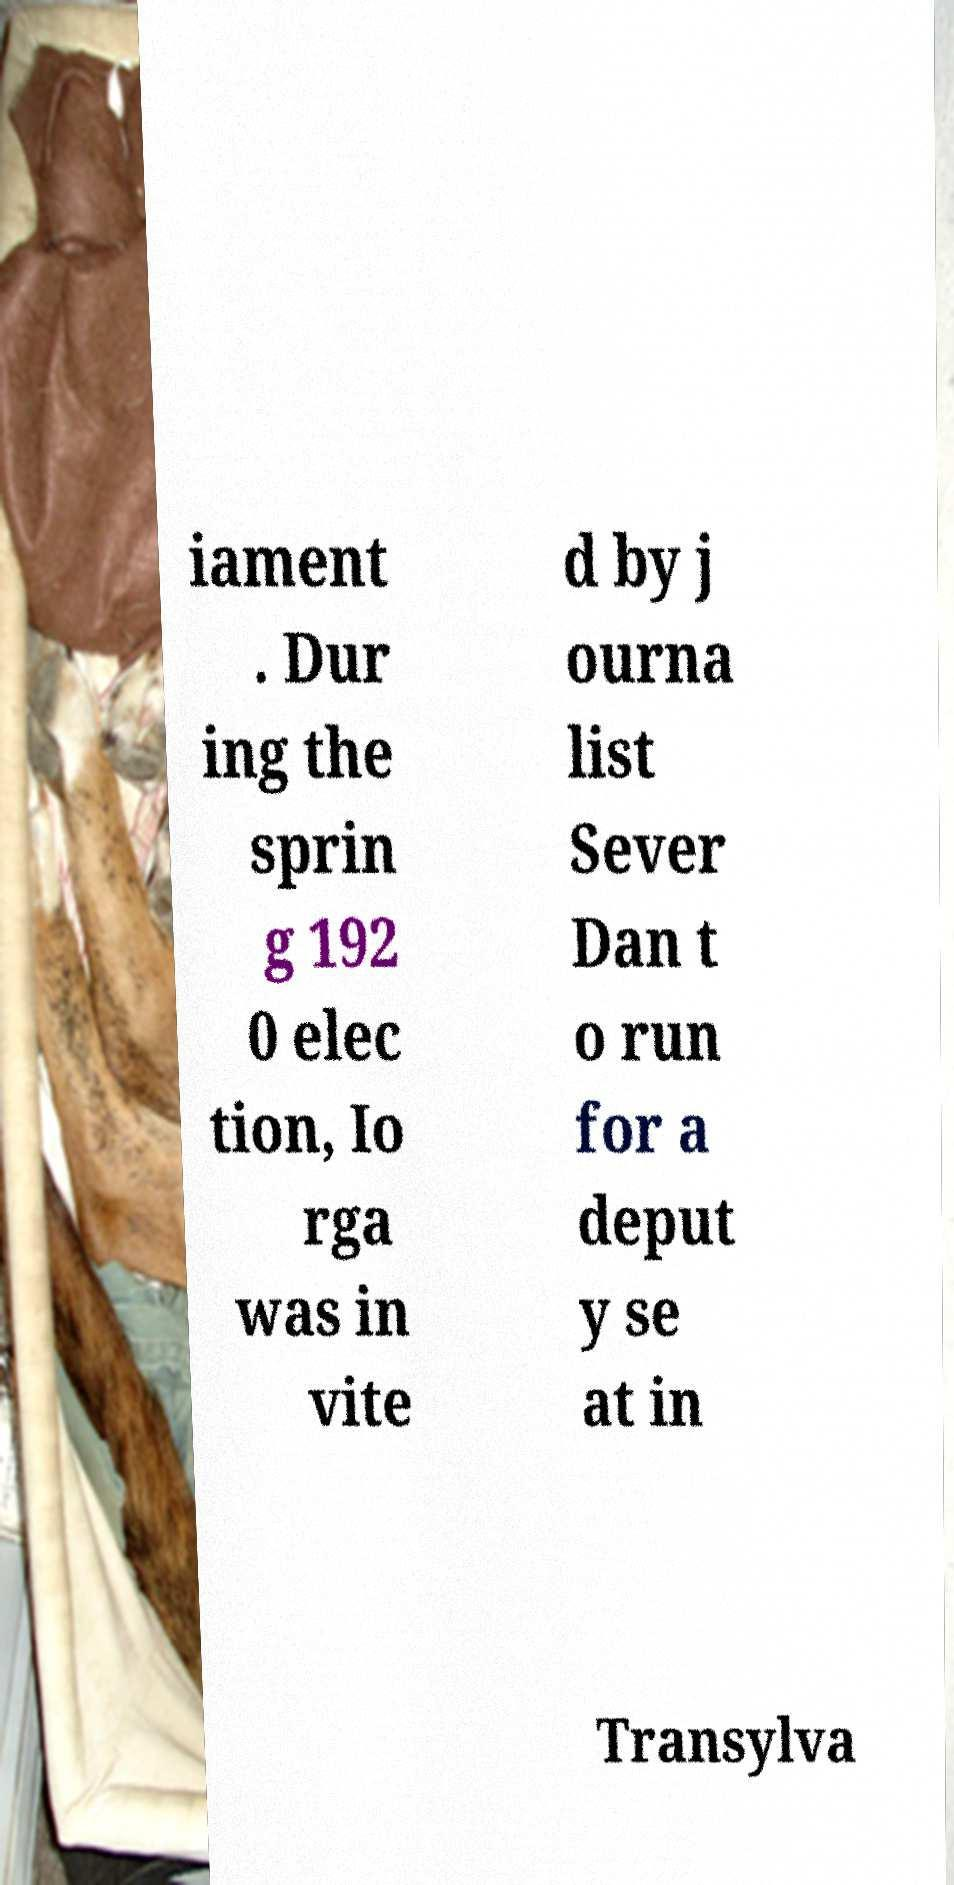Please identify and transcribe the text found in this image. iament . Dur ing the sprin g 192 0 elec tion, Io rga was in vite d by j ourna list Sever Dan t o run for a deput y se at in Transylva 